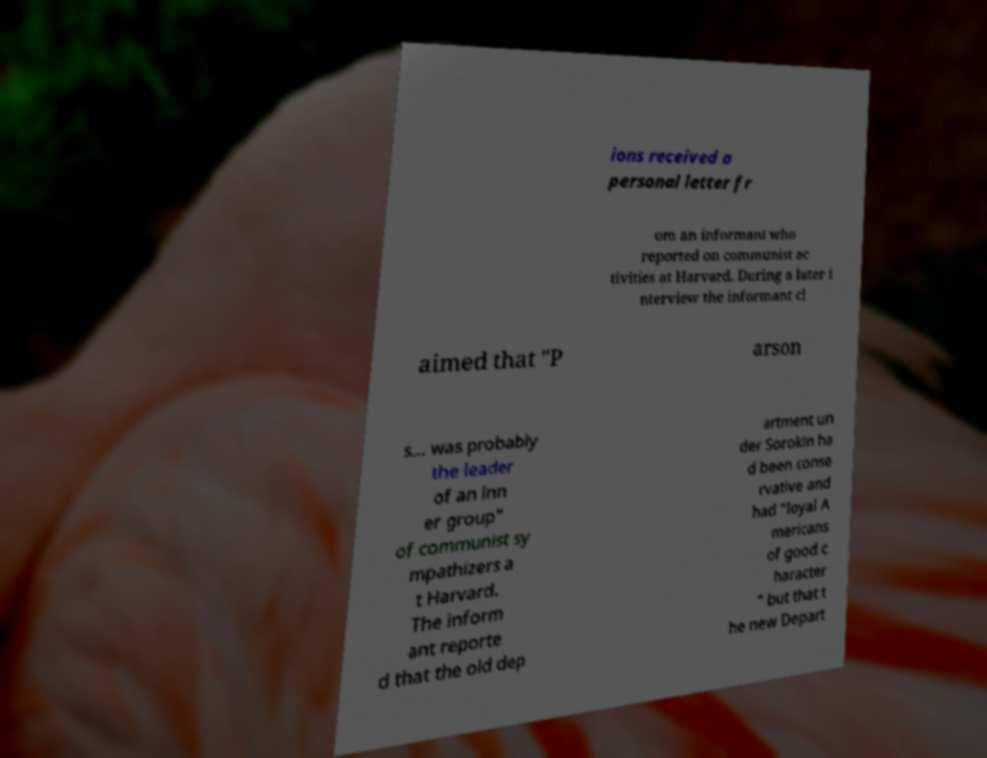Please read and relay the text visible in this image. What does it say? ions received a personal letter fr om an informant who reported on communist ac tivities at Harvard. During a later i nterview the informant cl aimed that "P arson s... was probably the leader of an inn er group" of communist sy mpathizers a t Harvard. The inform ant reporte d that the old dep artment un der Sorokin ha d been conse rvative and had "loyal A mericans of good c haracter " but that t he new Depart 